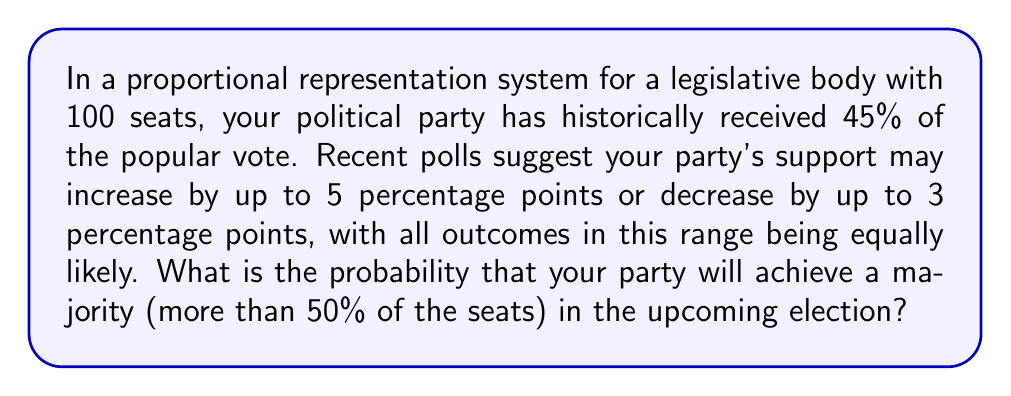Could you help me with this problem? Let's approach this step-by-step:

1) First, we need to define our probability space. The party's support can range from 42% to 50%, a total range of 8 percentage points.

2) To achieve a majority, the party needs more than 50% of the seats. In a perfectly proportional system, this means they need more than 50% of the vote.

3) The favorable outcomes are those where the party's support is greater than 50%. This occurs when the increase is more than 5 percentage points.

4) The probability can be calculated as:

   $$ P(\text{majority}) = \frac{\text{favorable outcomes}}{\text{total outcomes}} $$

5) The total range is 8 percentage points (from -3 to +5). The favorable range is from 5 to 5, which is 0 percentage points.

6) Therefore, the probability is:

   $$ P(\text{majority}) = \frac{0}{8} = 0 $$

This means that even with the most optimistic poll results, the party cannot achieve a majority in this election.

Note: In real-world proportional representation systems, there might be thresholds, rounding rules, or other factors that could slightly alter this probability. However, based on the given information and assuming a perfectly proportional system, this is the mathematically correct answer.
Answer: The probability of achieving a majority is 0. 